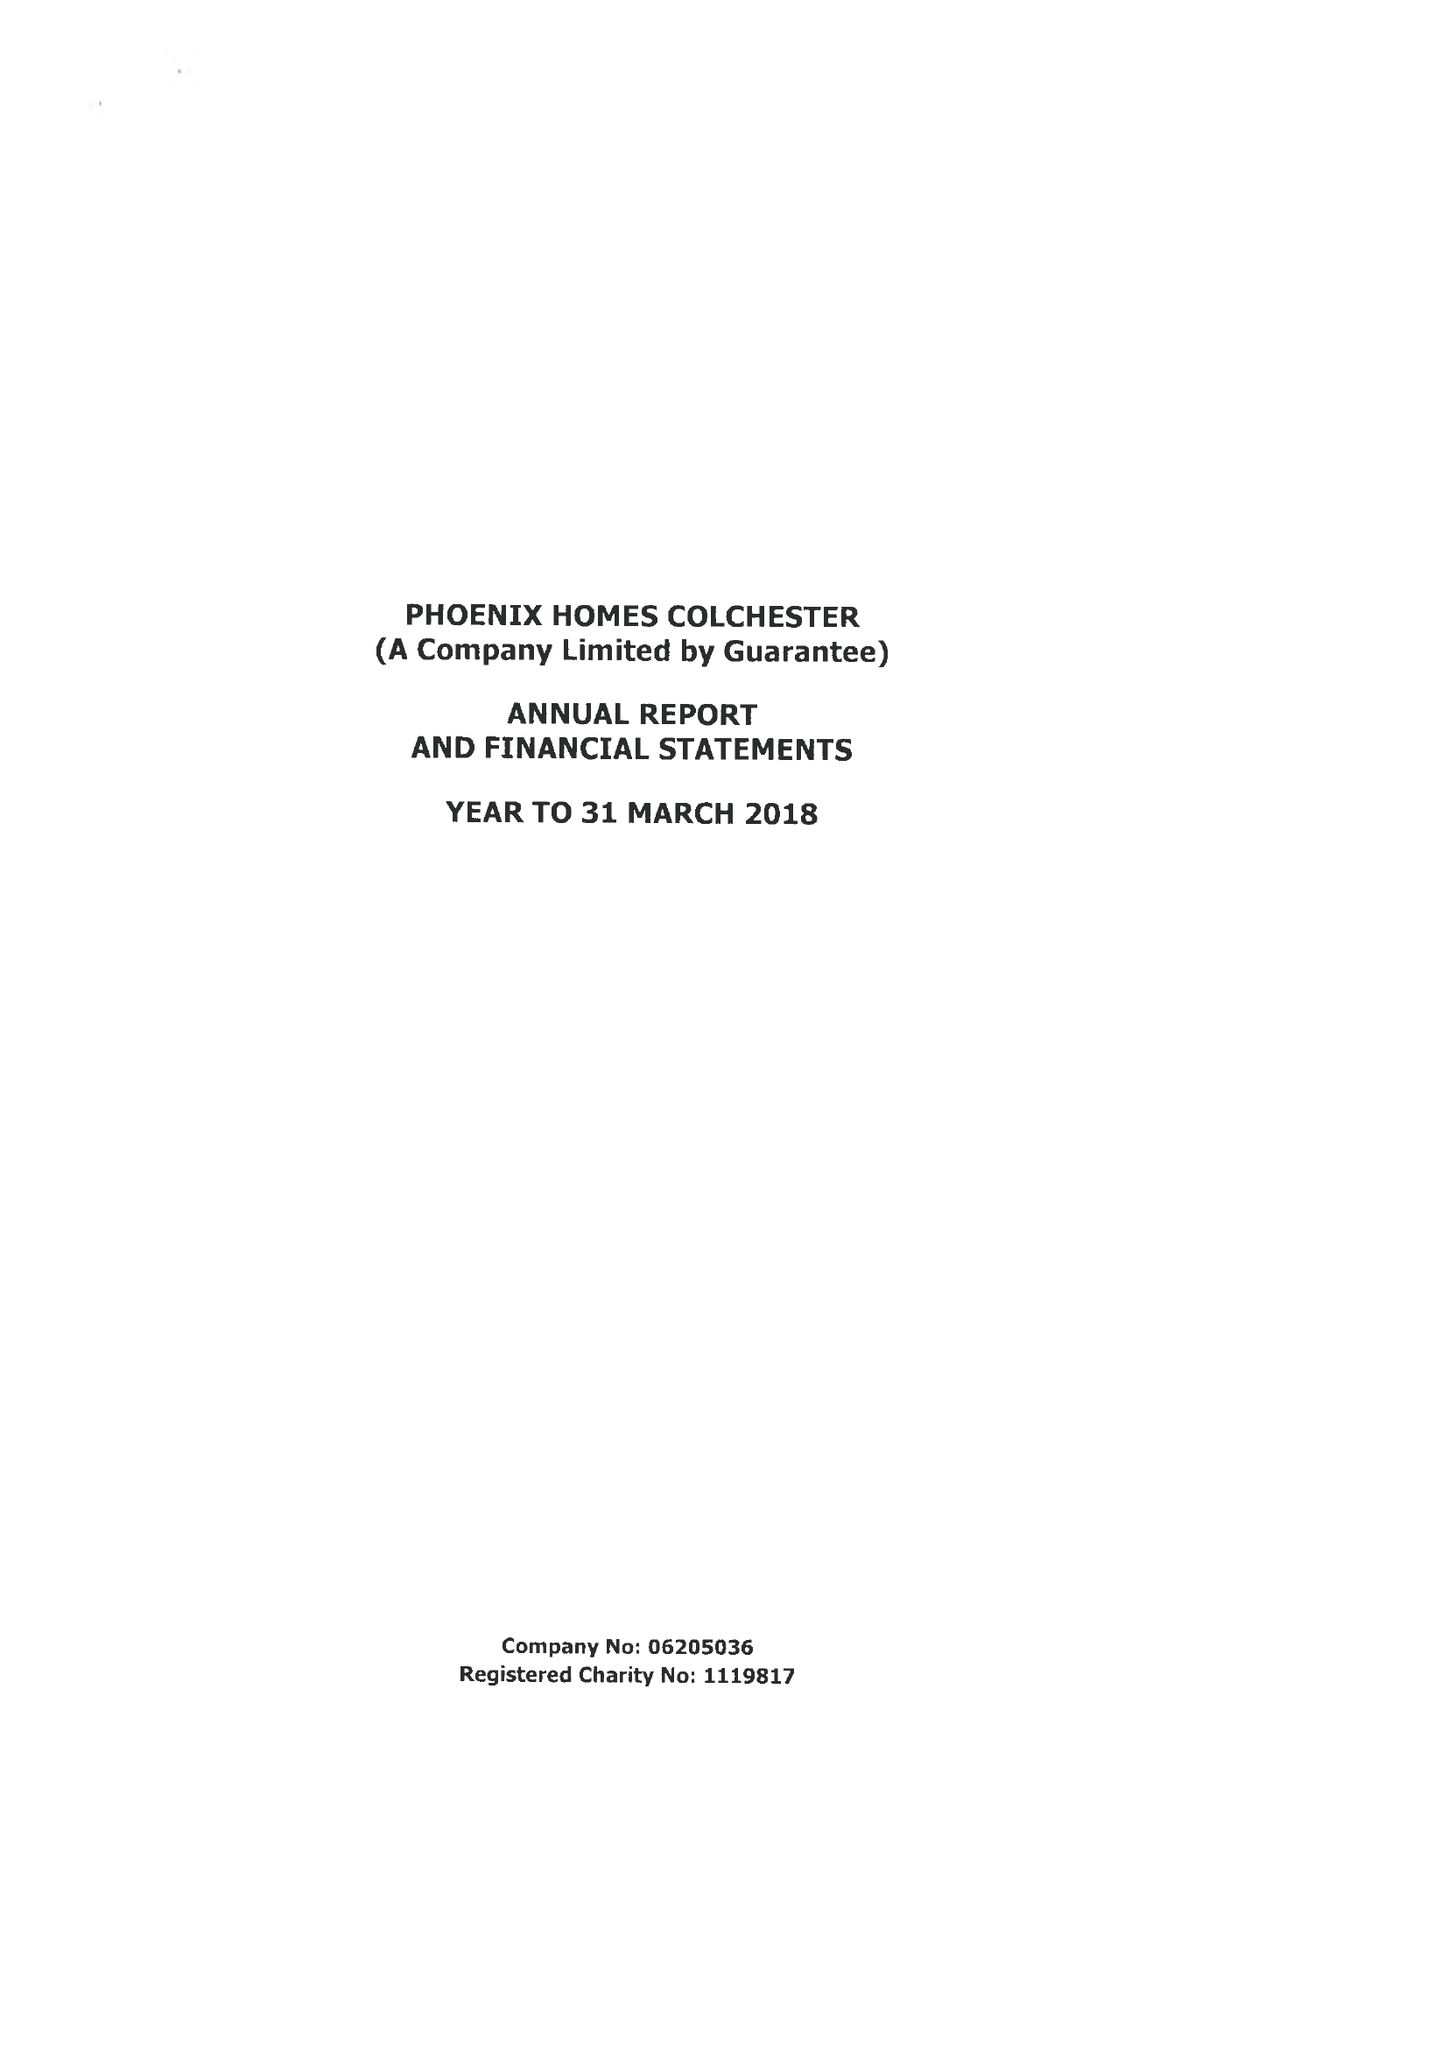What is the value for the charity_name?
Answer the question using a single word or phrase. Phoenix Homes Colchester 